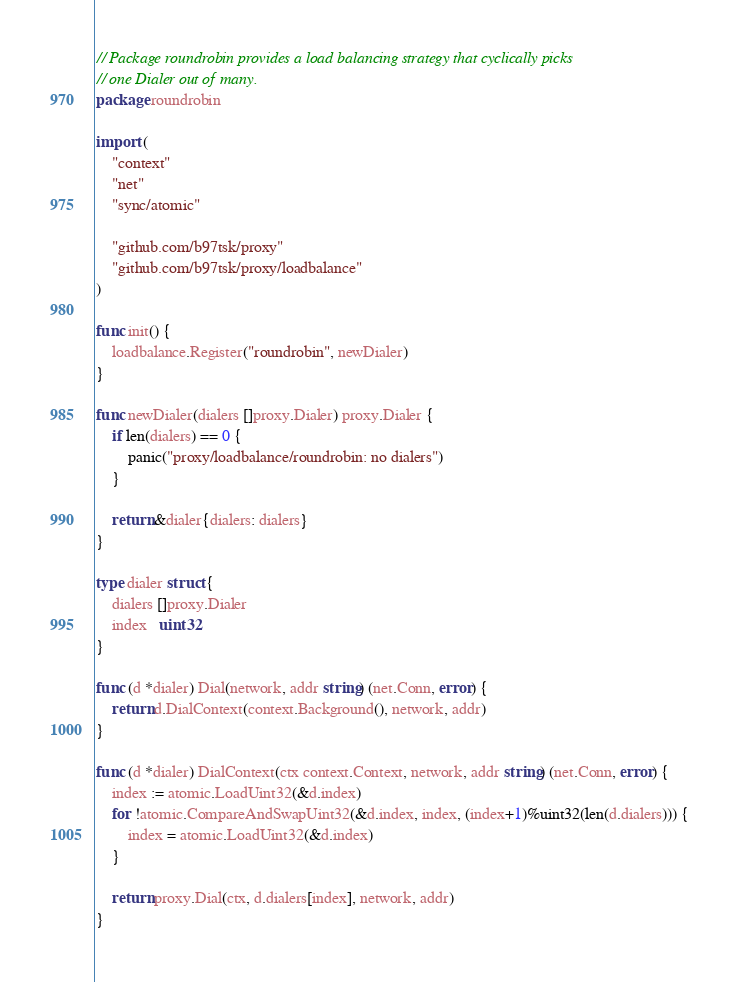Convert code to text. <code><loc_0><loc_0><loc_500><loc_500><_Go_>// Package roundrobin provides a load balancing strategy that cyclically picks
// one Dialer out of many.
package roundrobin

import (
	"context"
	"net"
	"sync/atomic"

	"github.com/b97tsk/proxy"
	"github.com/b97tsk/proxy/loadbalance"
)

func init() {
	loadbalance.Register("roundrobin", newDialer)
}

func newDialer(dialers []proxy.Dialer) proxy.Dialer {
	if len(dialers) == 0 {
		panic("proxy/loadbalance/roundrobin: no dialers")
	}

	return &dialer{dialers: dialers}
}

type dialer struct {
	dialers []proxy.Dialer
	index   uint32
}

func (d *dialer) Dial(network, addr string) (net.Conn, error) {
	return d.DialContext(context.Background(), network, addr)
}

func (d *dialer) DialContext(ctx context.Context, network, addr string) (net.Conn, error) {
	index := atomic.LoadUint32(&d.index)
	for !atomic.CompareAndSwapUint32(&d.index, index, (index+1)%uint32(len(d.dialers))) {
		index = atomic.LoadUint32(&d.index)
	}

	return proxy.Dial(ctx, d.dialers[index], network, addr)
}
</code> 